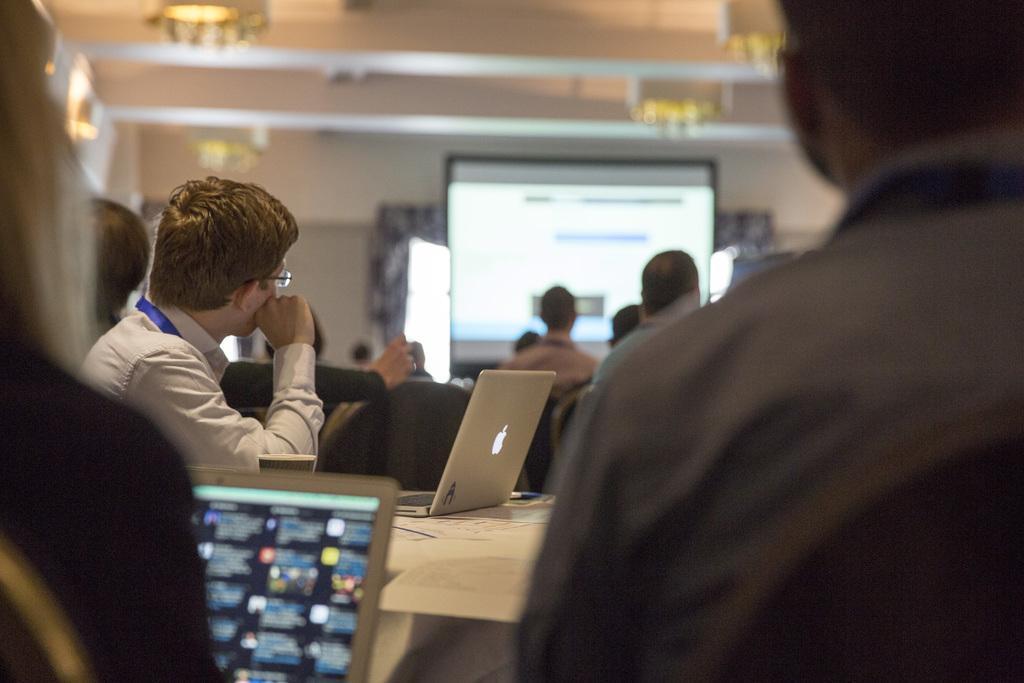Could you give a brief overview of what you see in this image? In this image there is a table on which there is a laptop. There are three people sitting in the chairs around the table. In the background there is a screen in the middle and there are people in front of it. At the top there is ceiling with the lights. On the left side there is a woman sitting in the chair and holding the laptop. 